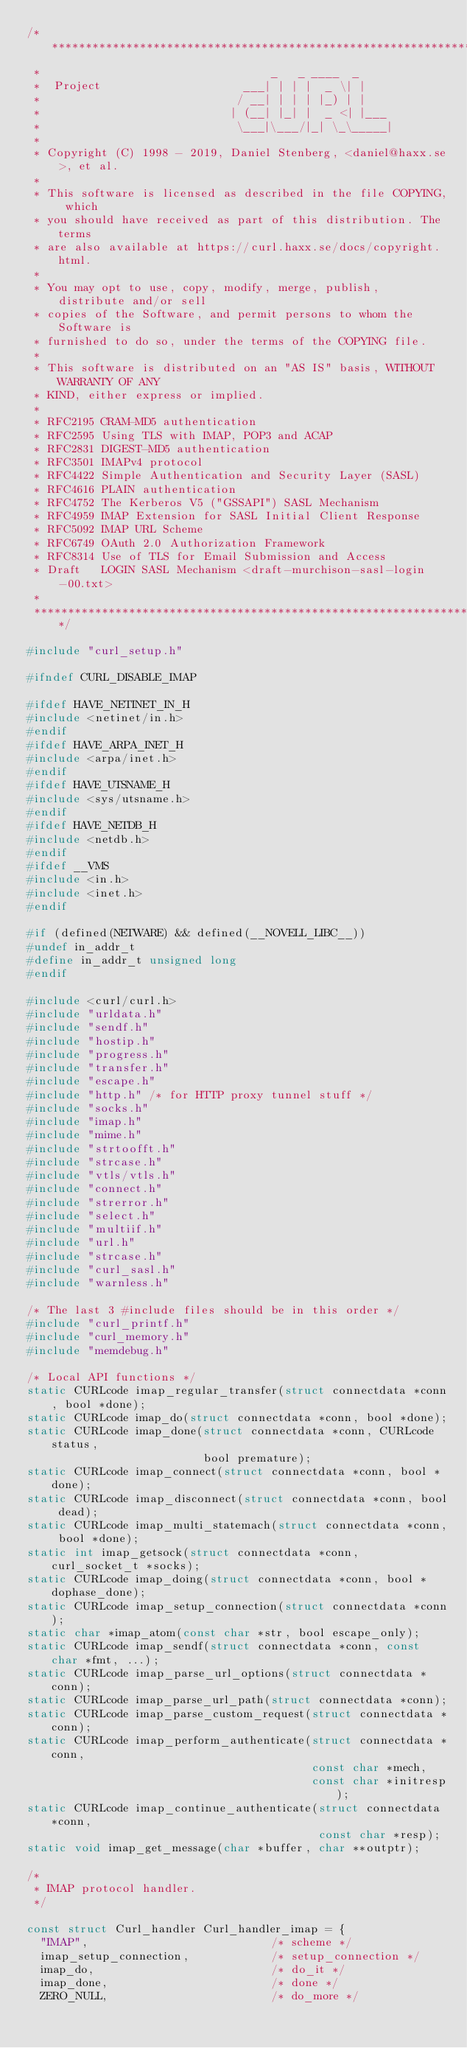Convert code to text. <code><loc_0><loc_0><loc_500><loc_500><_C_>/***************************************************************************
 *                                  _   _ ____  _
 *  Project                     ___| | | |  _ \| |
 *                             / __| | | | |_) | |
 *                            | (__| |_| |  _ <| |___
 *                             \___|\___/|_| \_\_____|
 *
 * Copyright (C) 1998 - 2019, Daniel Stenberg, <daniel@haxx.se>, et al.
 *
 * This software is licensed as described in the file COPYING, which
 * you should have received as part of this distribution. The terms
 * are also available at https://curl.haxx.se/docs/copyright.html.
 *
 * You may opt to use, copy, modify, merge, publish, distribute and/or sell
 * copies of the Software, and permit persons to whom the Software is
 * furnished to do so, under the terms of the COPYING file.
 *
 * This software is distributed on an "AS IS" basis, WITHOUT WARRANTY OF ANY
 * KIND, either express or implied.
 *
 * RFC2195 CRAM-MD5 authentication
 * RFC2595 Using TLS with IMAP, POP3 and ACAP
 * RFC2831 DIGEST-MD5 authentication
 * RFC3501 IMAPv4 protocol
 * RFC4422 Simple Authentication and Security Layer (SASL)
 * RFC4616 PLAIN authentication
 * RFC4752 The Kerberos V5 ("GSSAPI") SASL Mechanism
 * RFC4959 IMAP Extension for SASL Initial Client Response
 * RFC5092 IMAP URL Scheme
 * RFC6749 OAuth 2.0 Authorization Framework
 * RFC8314 Use of TLS for Email Submission and Access
 * Draft   LOGIN SASL Mechanism <draft-murchison-sasl-login-00.txt>
 *
 ***************************************************************************/

#include "curl_setup.h"

#ifndef CURL_DISABLE_IMAP

#ifdef HAVE_NETINET_IN_H
#include <netinet/in.h>
#endif
#ifdef HAVE_ARPA_INET_H
#include <arpa/inet.h>
#endif
#ifdef HAVE_UTSNAME_H
#include <sys/utsname.h>
#endif
#ifdef HAVE_NETDB_H
#include <netdb.h>
#endif
#ifdef __VMS
#include <in.h>
#include <inet.h>
#endif

#if (defined(NETWARE) && defined(__NOVELL_LIBC__))
#undef in_addr_t
#define in_addr_t unsigned long
#endif

#include <curl/curl.h>
#include "urldata.h"
#include "sendf.h"
#include "hostip.h"
#include "progress.h"
#include "transfer.h"
#include "escape.h"
#include "http.h" /* for HTTP proxy tunnel stuff */
#include "socks.h"
#include "imap.h"
#include "mime.h"
#include "strtoofft.h"
#include "strcase.h"
#include "vtls/vtls.h"
#include "connect.h"
#include "strerror.h"
#include "select.h"
#include "multiif.h"
#include "url.h"
#include "strcase.h"
#include "curl_sasl.h"
#include "warnless.h"

/* The last 3 #include files should be in this order */
#include "curl_printf.h"
#include "curl_memory.h"
#include "memdebug.h"

/* Local API functions */
static CURLcode imap_regular_transfer(struct connectdata *conn, bool *done);
static CURLcode imap_do(struct connectdata *conn, bool *done);
static CURLcode imap_done(struct connectdata *conn, CURLcode status,
                          bool premature);
static CURLcode imap_connect(struct connectdata *conn, bool *done);
static CURLcode imap_disconnect(struct connectdata *conn, bool dead);
static CURLcode imap_multi_statemach(struct connectdata *conn, bool *done);
static int imap_getsock(struct connectdata *conn, curl_socket_t *socks);
static CURLcode imap_doing(struct connectdata *conn, bool *dophase_done);
static CURLcode imap_setup_connection(struct connectdata *conn);
static char *imap_atom(const char *str, bool escape_only);
static CURLcode imap_sendf(struct connectdata *conn, const char *fmt, ...);
static CURLcode imap_parse_url_options(struct connectdata *conn);
static CURLcode imap_parse_url_path(struct connectdata *conn);
static CURLcode imap_parse_custom_request(struct connectdata *conn);
static CURLcode imap_perform_authenticate(struct connectdata *conn,
                                          const char *mech,
                                          const char *initresp);
static CURLcode imap_continue_authenticate(struct connectdata *conn,
                                           const char *resp);
static void imap_get_message(char *buffer, char **outptr);

/*
 * IMAP protocol handler.
 */

const struct Curl_handler Curl_handler_imap = {
  "IMAP",                           /* scheme */
  imap_setup_connection,            /* setup_connection */
  imap_do,                          /* do_it */
  imap_done,                        /* done */
  ZERO_NULL,                        /* do_more */</code> 